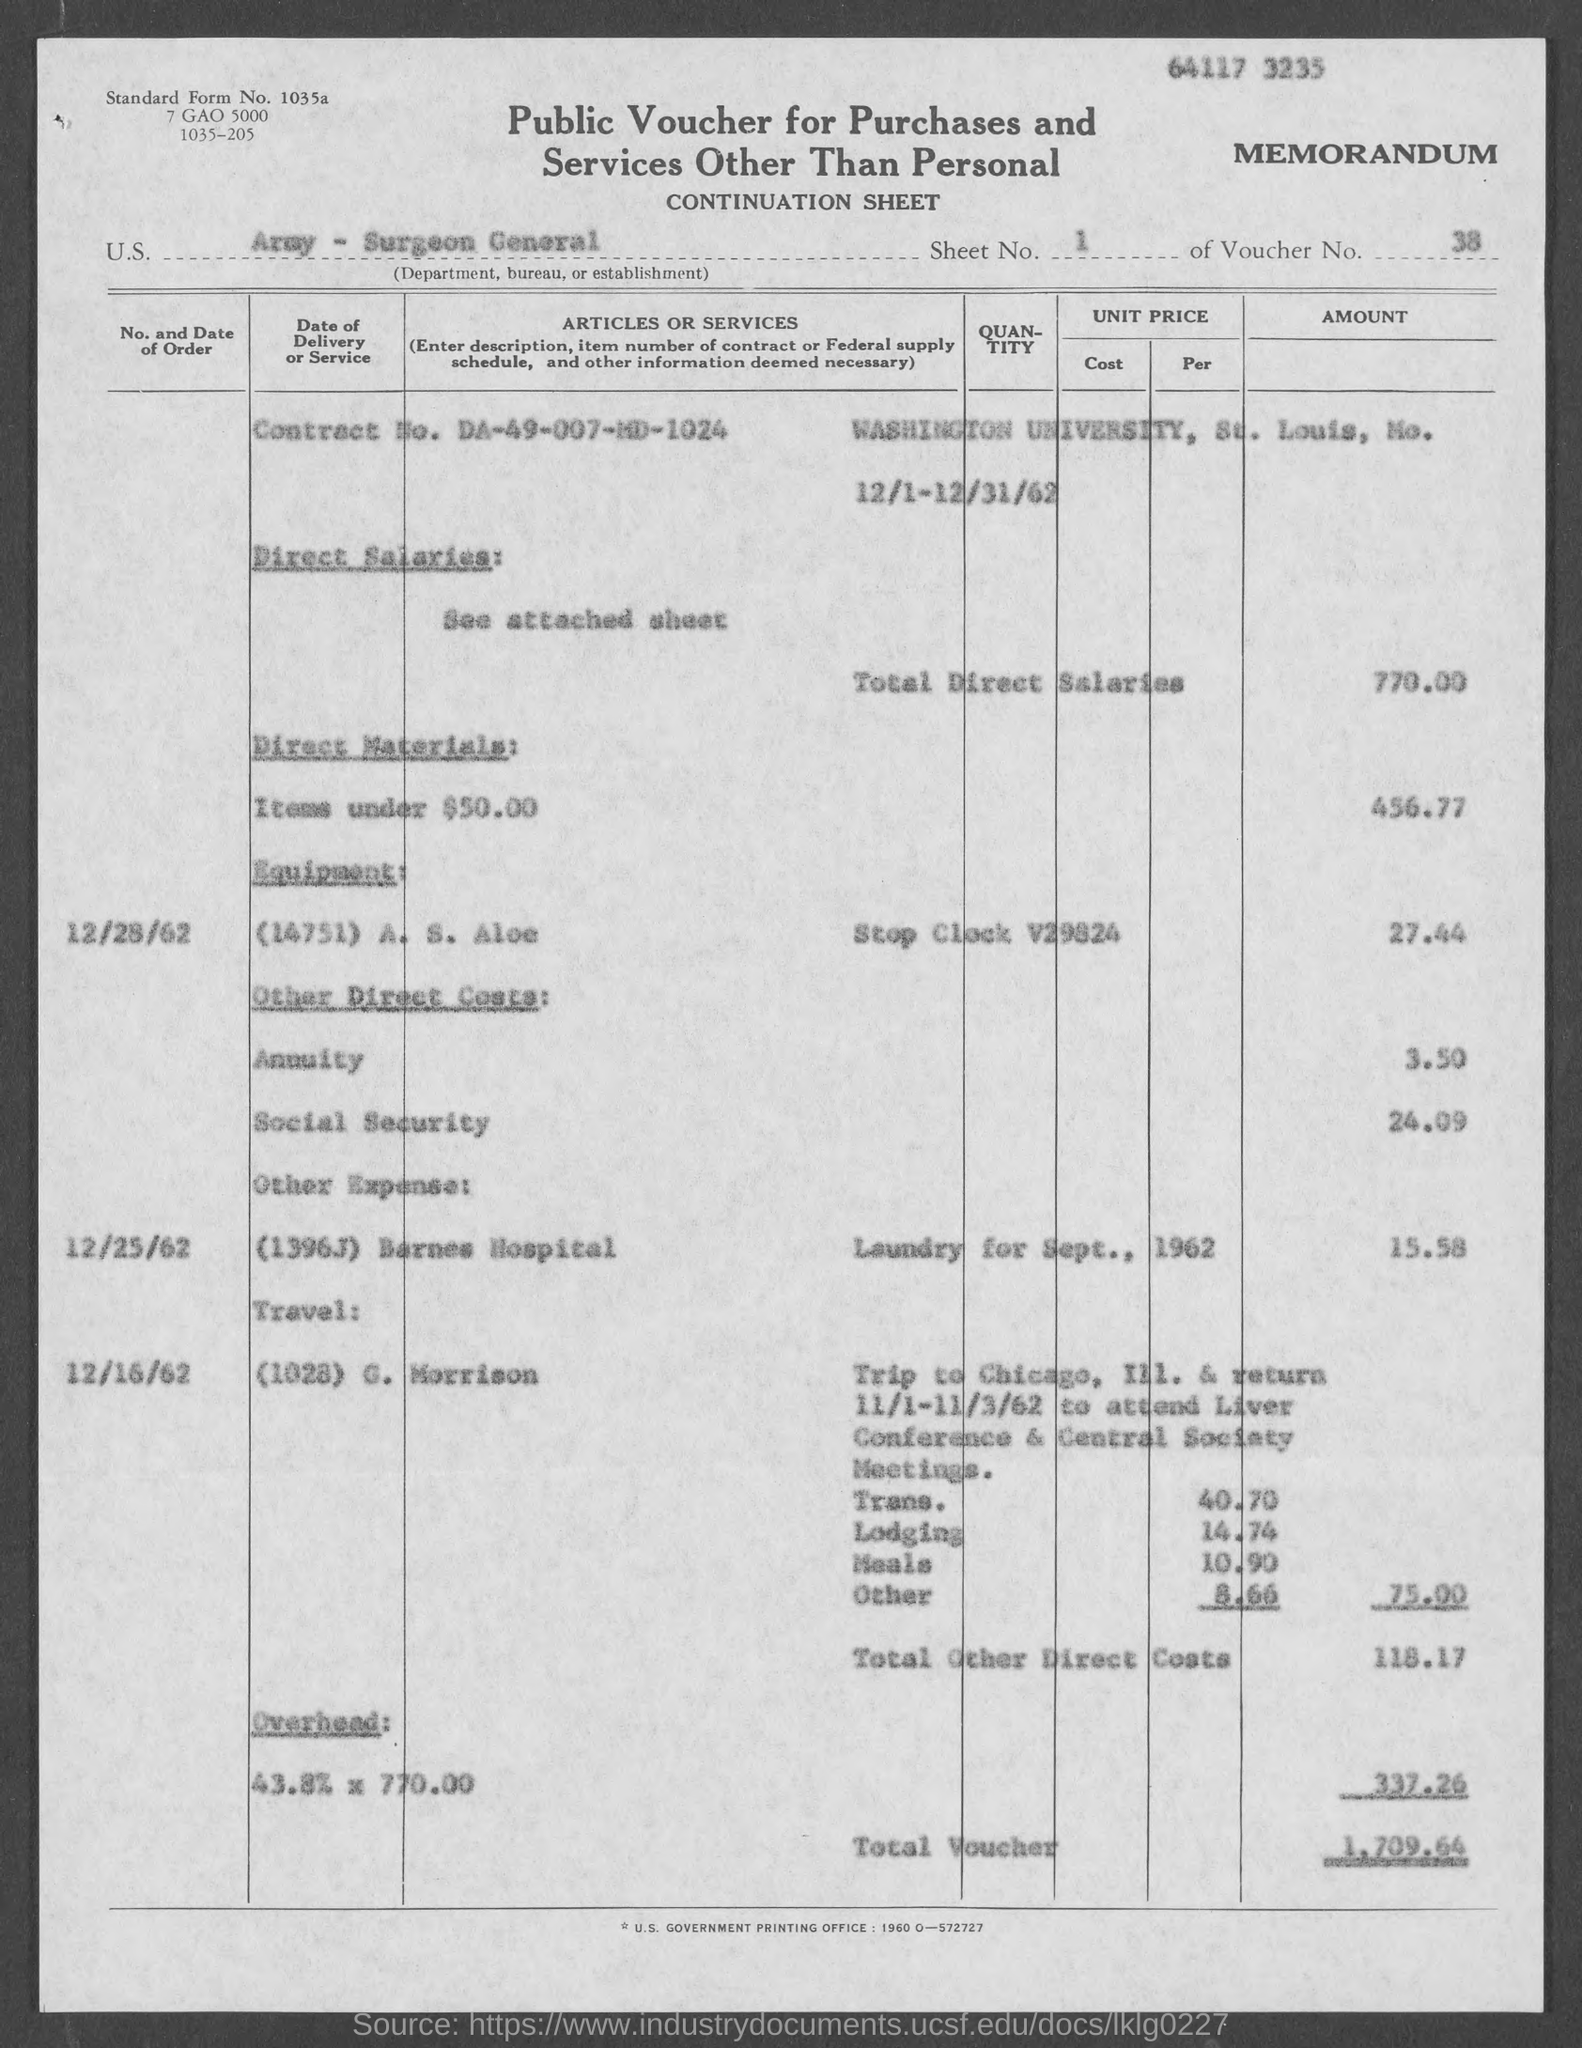List a handful of essential elements in this visual. The total voucher is 1,709.64. The voucher number is 38. What is the sheet number?" refers to the question of asking for information about the number of a sheet. The Surgeon General's Department of the Army is mentioned. 